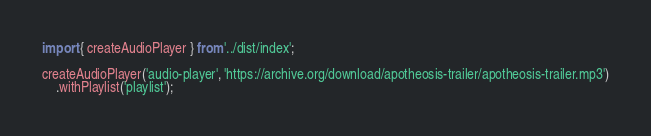Convert code to text. <code><loc_0><loc_0><loc_500><loc_500><_TypeScript_>import { createAudioPlayer } from '../dist/index';

createAudioPlayer('audio-player', 'https://archive.org/download/apotheosis-trailer/apotheosis-trailer.mp3')
    .withPlaylist('playlist');
</code> 